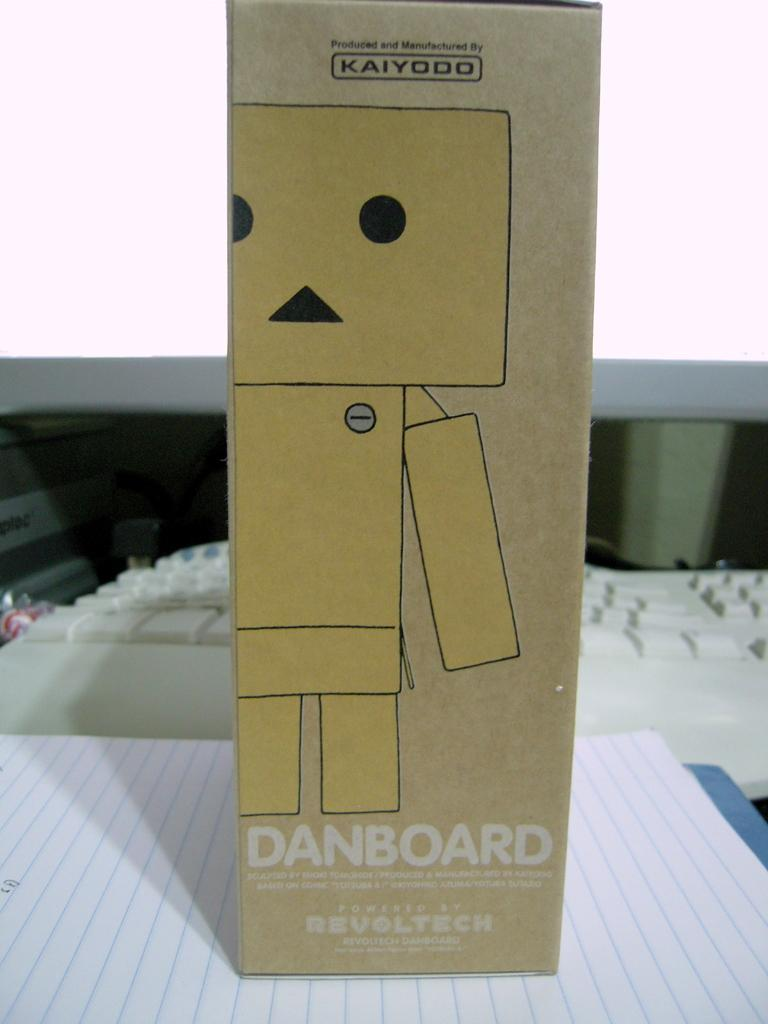Provide a one-sentence caption for the provided image. the word danboard is on the brown box. 